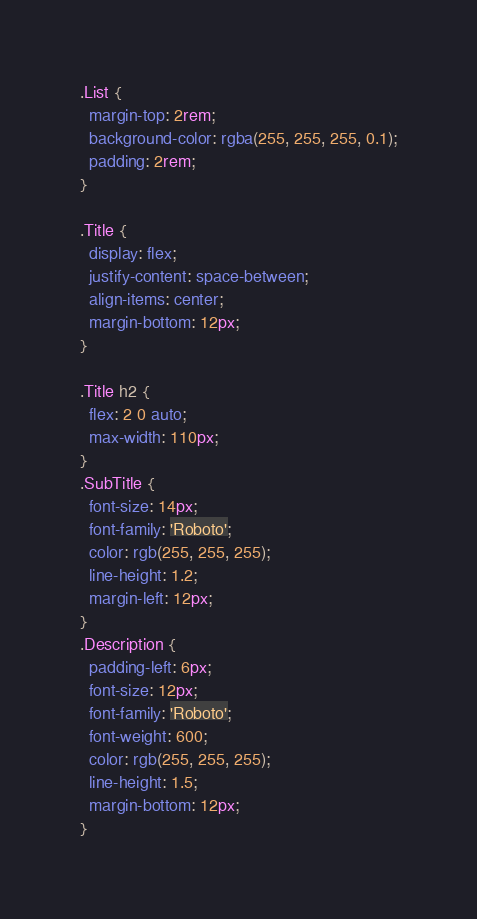Convert code to text. <code><loc_0><loc_0><loc_500><loc_500><_CSS_>.List {
  margin-top: 2rem;
  background-color: rgba(255, 255, 255, 0.1);
  padding: 2rem;
}

.Title {
  display: flex;
  justify-content: space-between;
  align-items: center;
  margin-bottom: 12px;
}

.Title h2 {
  flex: 2 0 auto;
  max-width: 110px;
}
.SubTitle {
  font-size: 14px;
  font-family: 'Roboto';
  color: rgb(255, 255, 255);
  line-height: 1.2;
  margin-left: 12px;
}
.Description {
  padding-left: 6px;
  font-size: 12px;
  font-family: 'Roboto';
  font-weight: 600;
  color: rgb(255, 255, 255);
  line-height: 1.5;
  margin-bottom: 12px;
}
</code> 